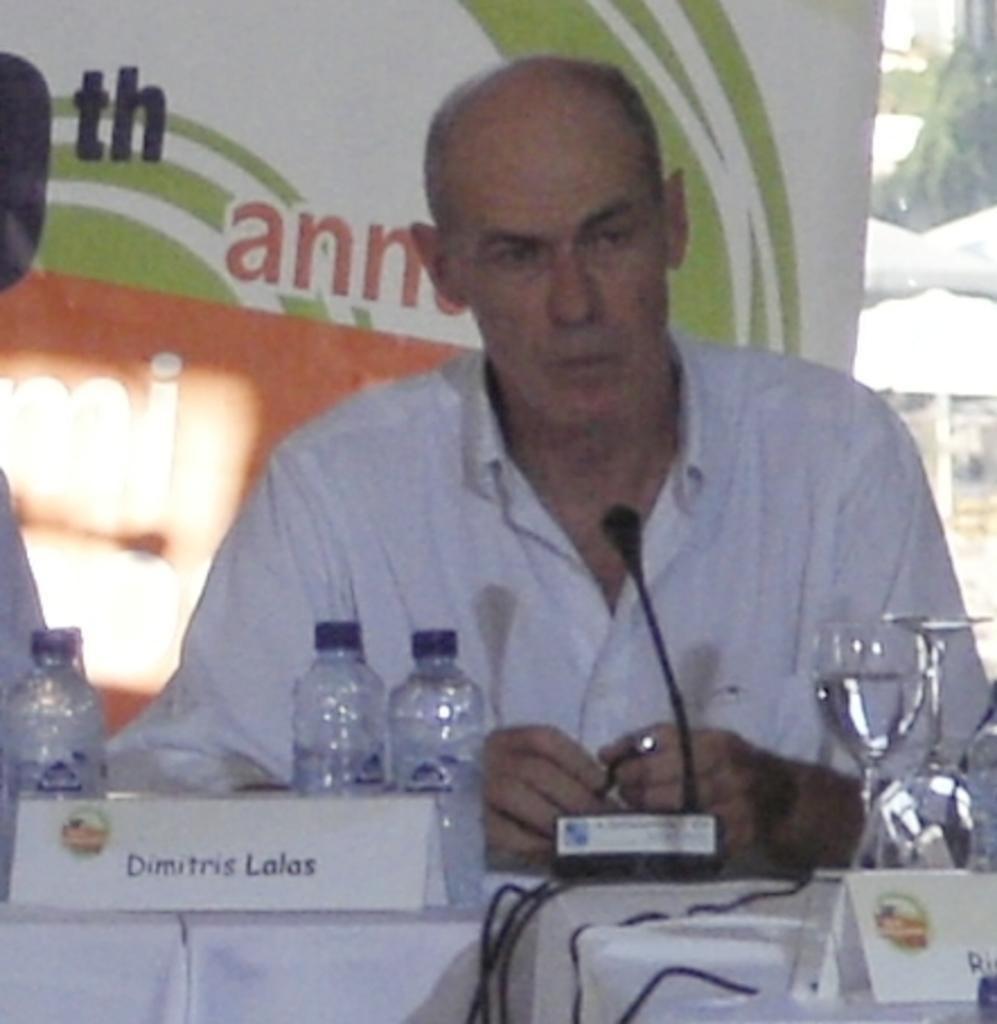What is the man in the image doing? The man is sitting in the middle of the image. What is the man positioned in front of? The man is in front of a microphone. What can be seen behind the man? There is a banner behind the man. What items are on the table in front of the man? There are water bottles and glasses on the table in front of the man. What type of rake is being used by the man in the image? There is no rake present in the image; the man is sitting in front of a microphone. What type of skirt is the man wearing in the image? The man is not wearing a skirt in the image; he is wearing clothing that is not specified in the provided facts, but there is no mention of a skirt or any specific clothing in the image. 